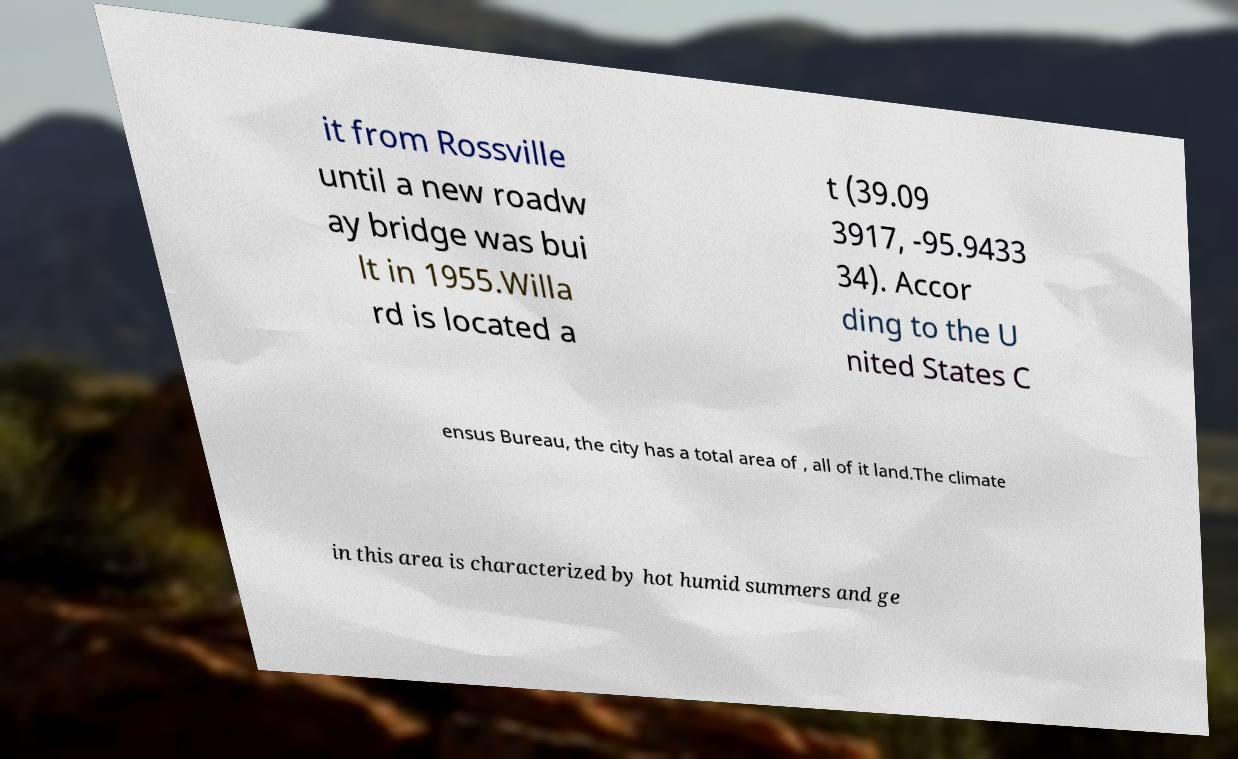I need the written content from this picture converted into text. Can you do that? it from Rossville until a new roadw ay bridge was bui lt in 1955.Willa rd is located a t (39.09 3917, -95.9433 34). Accor ding to the U nited States C ensus Bureau, the city has a total area of , all of it land.The climate in this area is characterized by hot humid summers and ge 